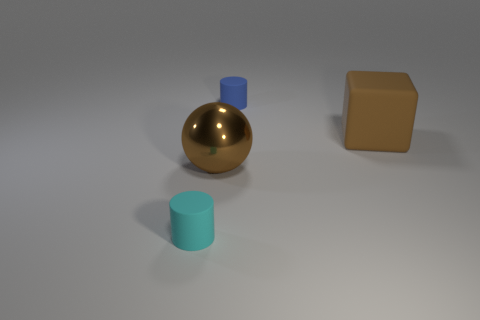Add 4 large brown things. How many objects exist? 8 Subtract 2 cylinders. How many cylinders are left? 0 Subtract all cyan cylinders. How many cylinders are left? 1 Subtract all brown cylinders. How many blue spheres are left? 0 Add 3 small objects. How many small objects are left? 5 Add 2 blue things. How many blue things exist? 3 Subtract 0 brown cylinders. How many objects are left? 4 Subtract all cubes. How many objects are left? 3 Subtract all green cylinders. Subtract all gray spheres. How many cylinders are left? 2 Subtract all big red rubber balls. Subtract all big brown things. How many objects are left? 2 